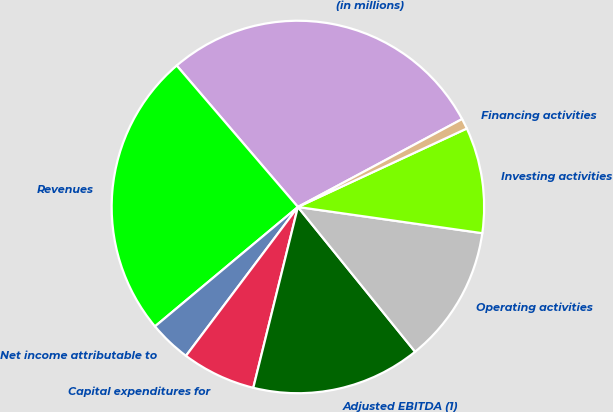Convert chart. <chart><loc_0><loc_0><loc_500><loc_500><pie_chart><fcel>(in millions)<fcel>Revenues<fcel>Net income attributable to<fcel>Capital expenditures for<fcel>Adjusted EBITDA (1)<fcel>Operating activities<fcel>Investing activities<fcel>Financing activities<nl><fcel>28.45%<fcel>24.8%<fcel>3.66%<fcel>6.41%<fcel>14.68%<fcel>11.92%<fcel>9.17%<fcel>0.9%<nl></chart> 